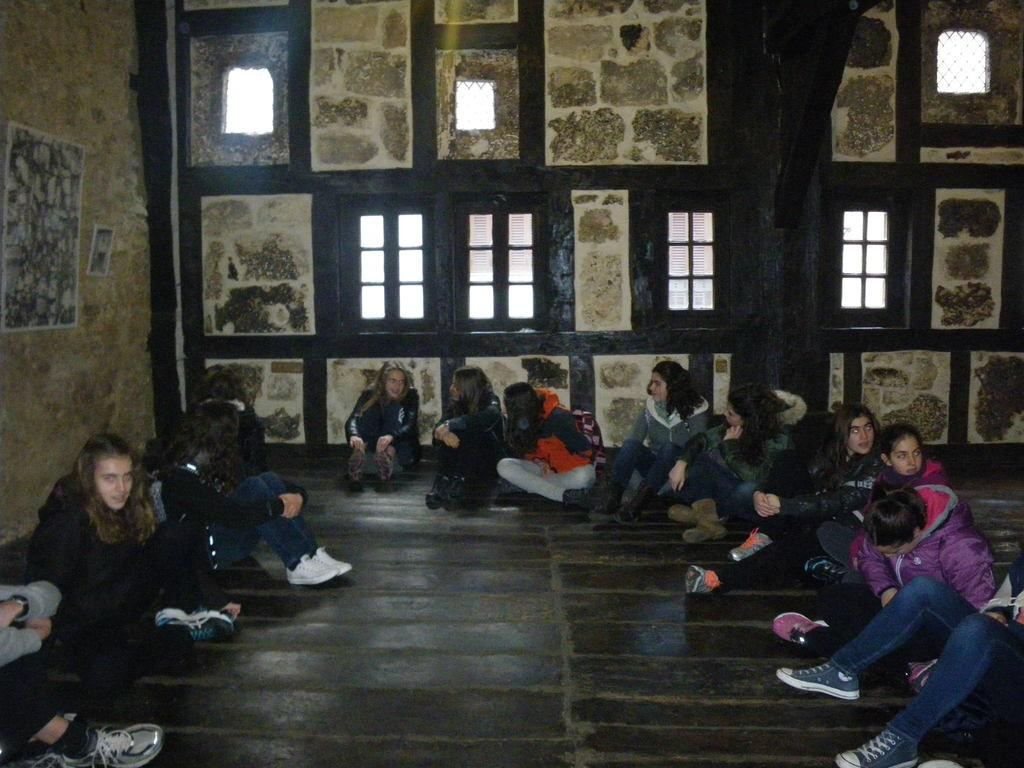What are the people in the image doing? The people in the image are sitting on the floor. What can be seen behind the people? There is a wall visible in the image. Is there any natural light coming into the room? Yes, there is a window visible in the image. What type of skin can be seen on the people's wings in the image? There are no people with wings in the image, so there is no skin to describe. 